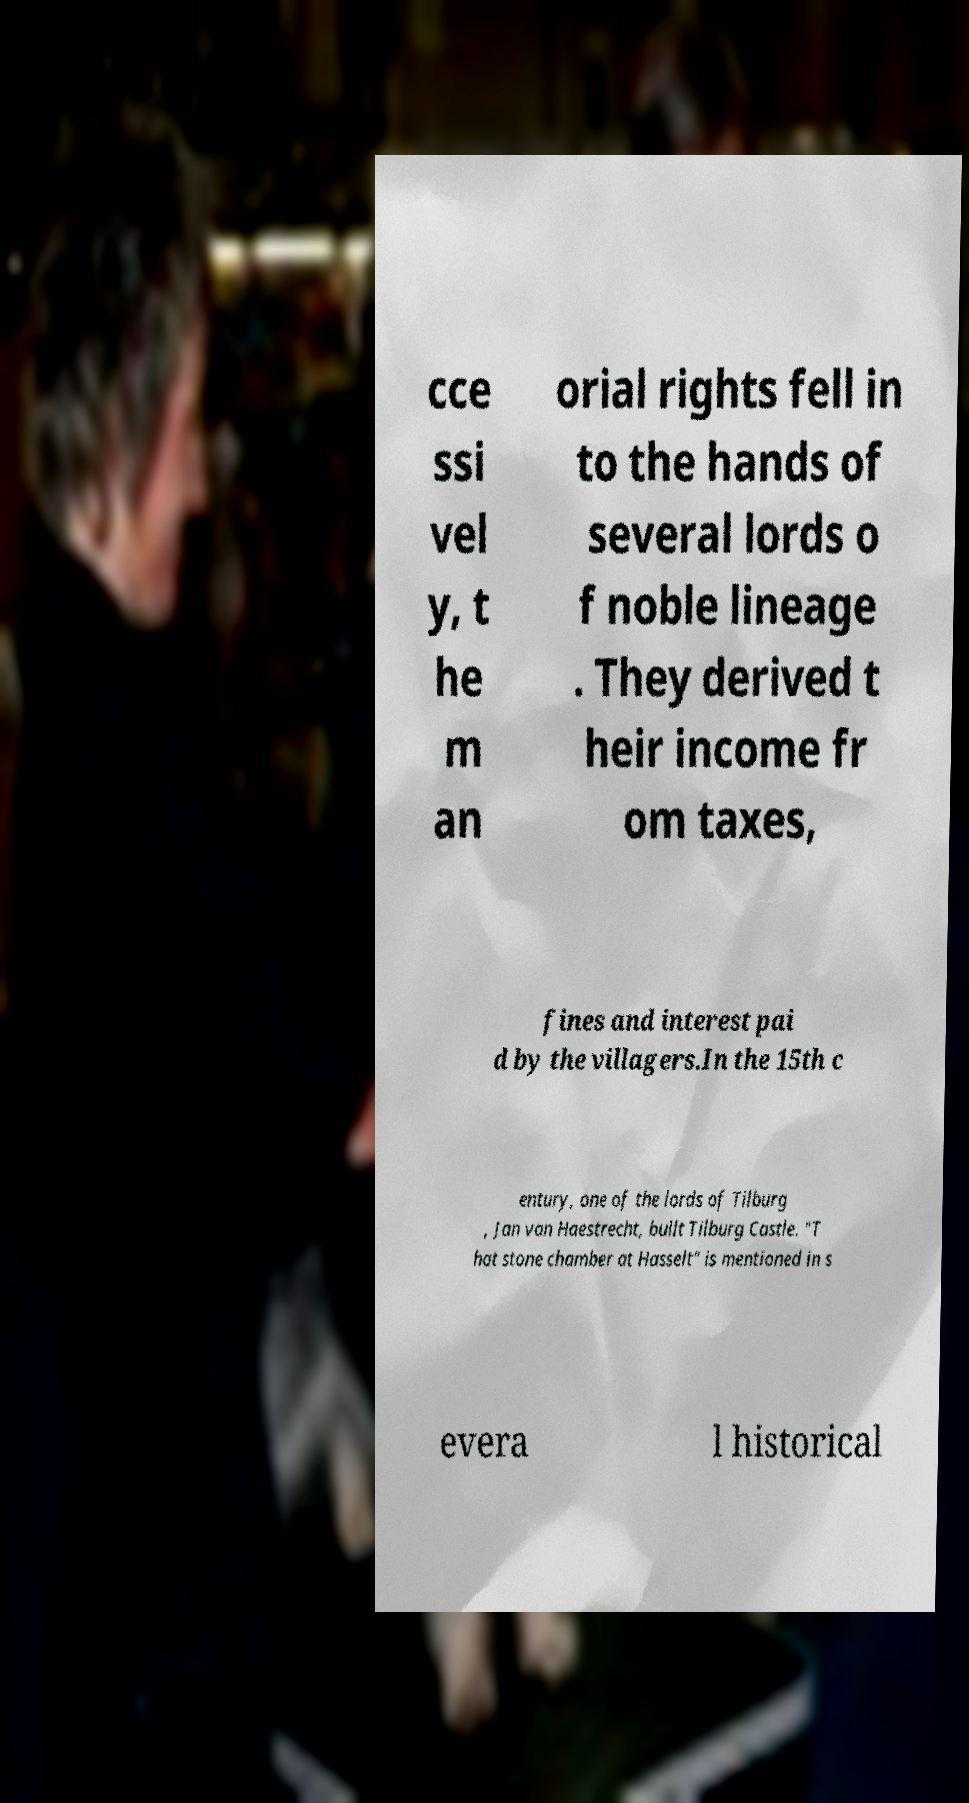Please read and relay the text visible in this image. What does it say? cce ssi vel y, t he m an orial rights fell in to the hands of several lords o f noble lineage . They derived t heir income fr om taxes, fines and interest pai d by the villagers.In the 15th c entury, one of the lords of Tilburg , Jan van Haestrecht, built Tilburg Castle. "T hat stone chamber at Hasselt" is mentioned in s evera l historical 